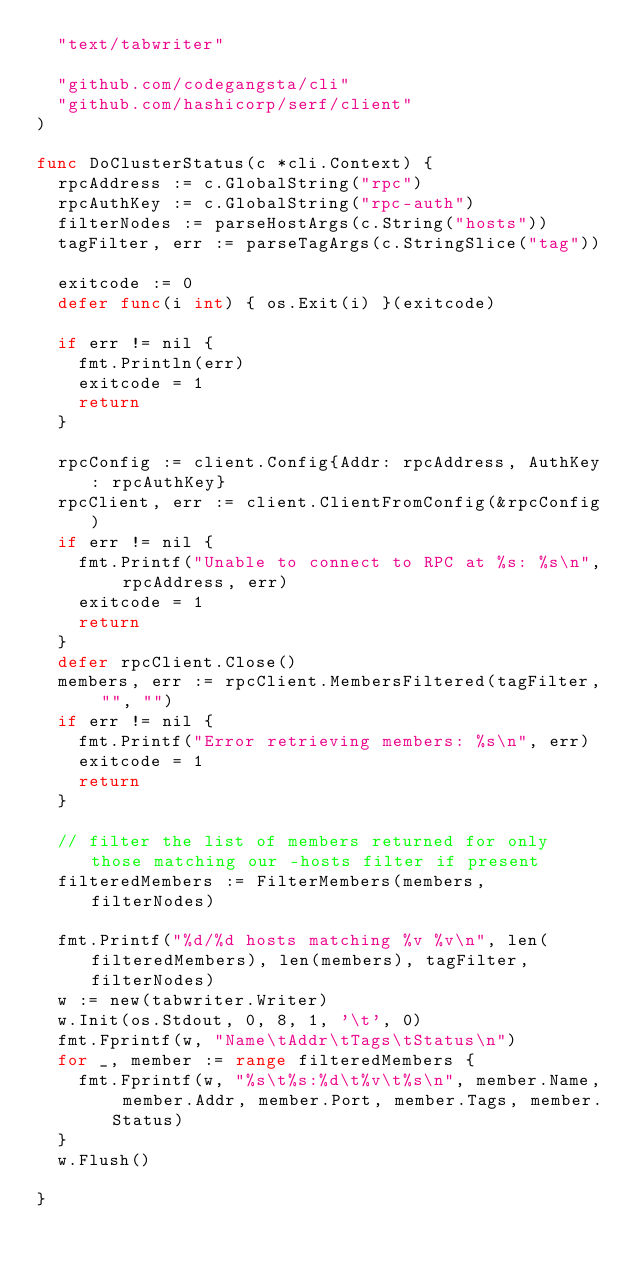<code> <loc_0><loc_0><loc_500><loc_500><_Go_>	"text/tabwriter"

	"github.com/codegangsta/cli"
	"github.com/hashicorp/serf/client"
)

func DoClusterStatus(c *cli.Context) {
	rpcAddress := c.GlobalString("rpc")
	rpcAuthKey := c.GlobalString("rpc-auth")
	filterNodes := parseHostArgs(c.String("hosts"))
	tagFilter, err := parseTagArgs(c.StringSlice("tag"))

	exitcode := 0
	defer func(i int) { os.Exit(i) }(exitcode)

	if err != nil {
		fmt.Println(err)
		exitcode = 1
		return
	}

	rpcConfig := client.Config{Addr: rpcAddress, AuthKey: rpcAuthKey}
	rpcClient, err := client.ClientFromConfig(&rpcConfig)
	if err != nil {
		fmt.Printf("Unable to connect to RPC at %s: %s\n", rpcAddress, err)
		exitcode = 1
		return
	}
	defer rpcClient.Close()
	members, err := rpcClient.MembersFiltered(tagFilter, "", "")
	if err != nil {
		fmt.Printf("Error retrieving members: %s\n", err)
		exitcode = 1
		return
	}

	// filter the list of members returned for only those matching our -hosts filter if present
	filteredMembers := FilterMembers(members, filterNodes)

	fmt.Printf("%d/%d hosts matching %v %v\n", len(filteredMembers), len(members), tagFilter, filterNodes)
	w := new(tabwriter.Writer)
	w.Init(os.Stdout, 0, 8, 1, '\t', 0)
	fmt.Fprintf(w, "Name\tAddr\tTags\tStatus\n")
	for _, member := range filteredMembers {
		fmt.Fprintf(w, "%s\t%s:%d\t%v\t%s\n", member.Name, member.Addr, member.Port, member.Tags, member.Status)
	}
	w.Flush()

}
</code> 